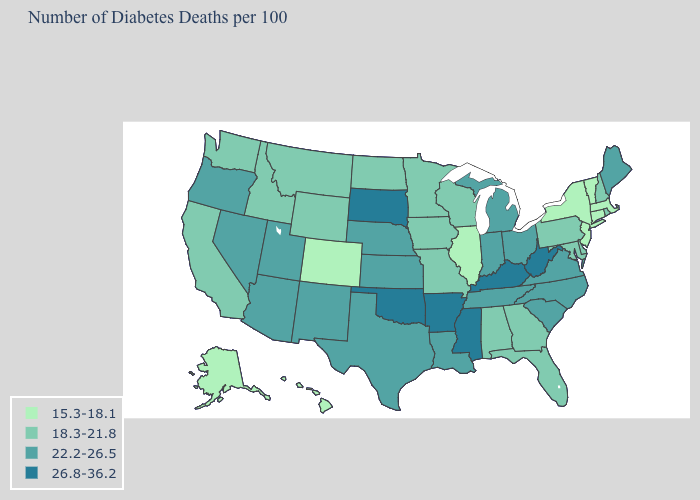Does the first symbol in the legend represent the smallest category?
Write a very short answer. Yes. Name the states that have a value in the range 18.3-21.8?
Concise answer only. Alabama, California, Delaware, Florida, Georgia, Idaho, Iowa, Maryland, Minnesota, Missouri, Montana, New Hampshire, North Dakota, Pennsylvania, Rhode Island, Washington, Wisconsin, Wyoming. What is the value of North Dakota?
Short answer required. 18.3-21.8. What is the highest value in states that border New Hampshire?
Give a very brief answer. 22.2-26.5. What is the value of New Mexico?
Write a very short answer. 22.2-26.5. Does the map have missing data?
Write a very short answer. No. Name the states that have a value in the range 26.8-36.2?
Keep it brief. Arkansas, Kentucky, Mississippi, Oklahoma, South Dakota, West Virginia. What is the value of Kansas?
Keep it brief. 22.2-26.5. Name the states that have a value in the range 22.2-26.5?
Be succinct. Arizona, Indiana, Kansas, Louisiana, Maine, Michigan, Nebraska, Nevada, New Mexico, North Carolina, Ohio, Oregon, South Carolina, Tennessee, Texas, Utah, Virginia. What is the value of Hawaii?
Be succinct. 15.3-18.1. Among the states that border New Hampshire , which have the highest value?
Quick response, please. Maine. What is the highest value in the South ?
Quick response, please. 26.8-36.2. What is the value of Kentucky?
Write a very short answer. 26.8-36.2. Name the states that have a value in the range 15.3-18.1?
Keep it brief. Alaska, Colorado, Connecticut, Hawaii, Illinois, Massachusetts, New Jersey, New York, Vermont. What is the lowest value in states that border Massachusetts?
Answer briefly. 15.3-18.1. 